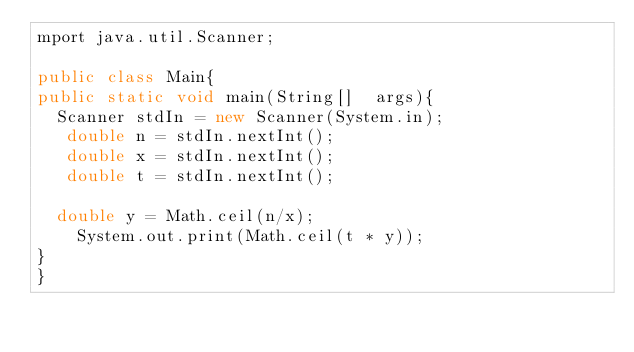Convert code to text. <code><loc_0><loc_0><loc_500><loc_500><_Java_>mport java.util.Scanner;

public class Main{
public static void main(String[]  args){
  Scanner stdIn = new Scanner(System.in);
   double n = stdIn.nextInt();
   double x = stdIn.nextInt();
   double t = stdIn.nextInt();

  double y = Math.ceil(n/x);
    System.out.print(Math.ceil(t * y));
}
}</code> 